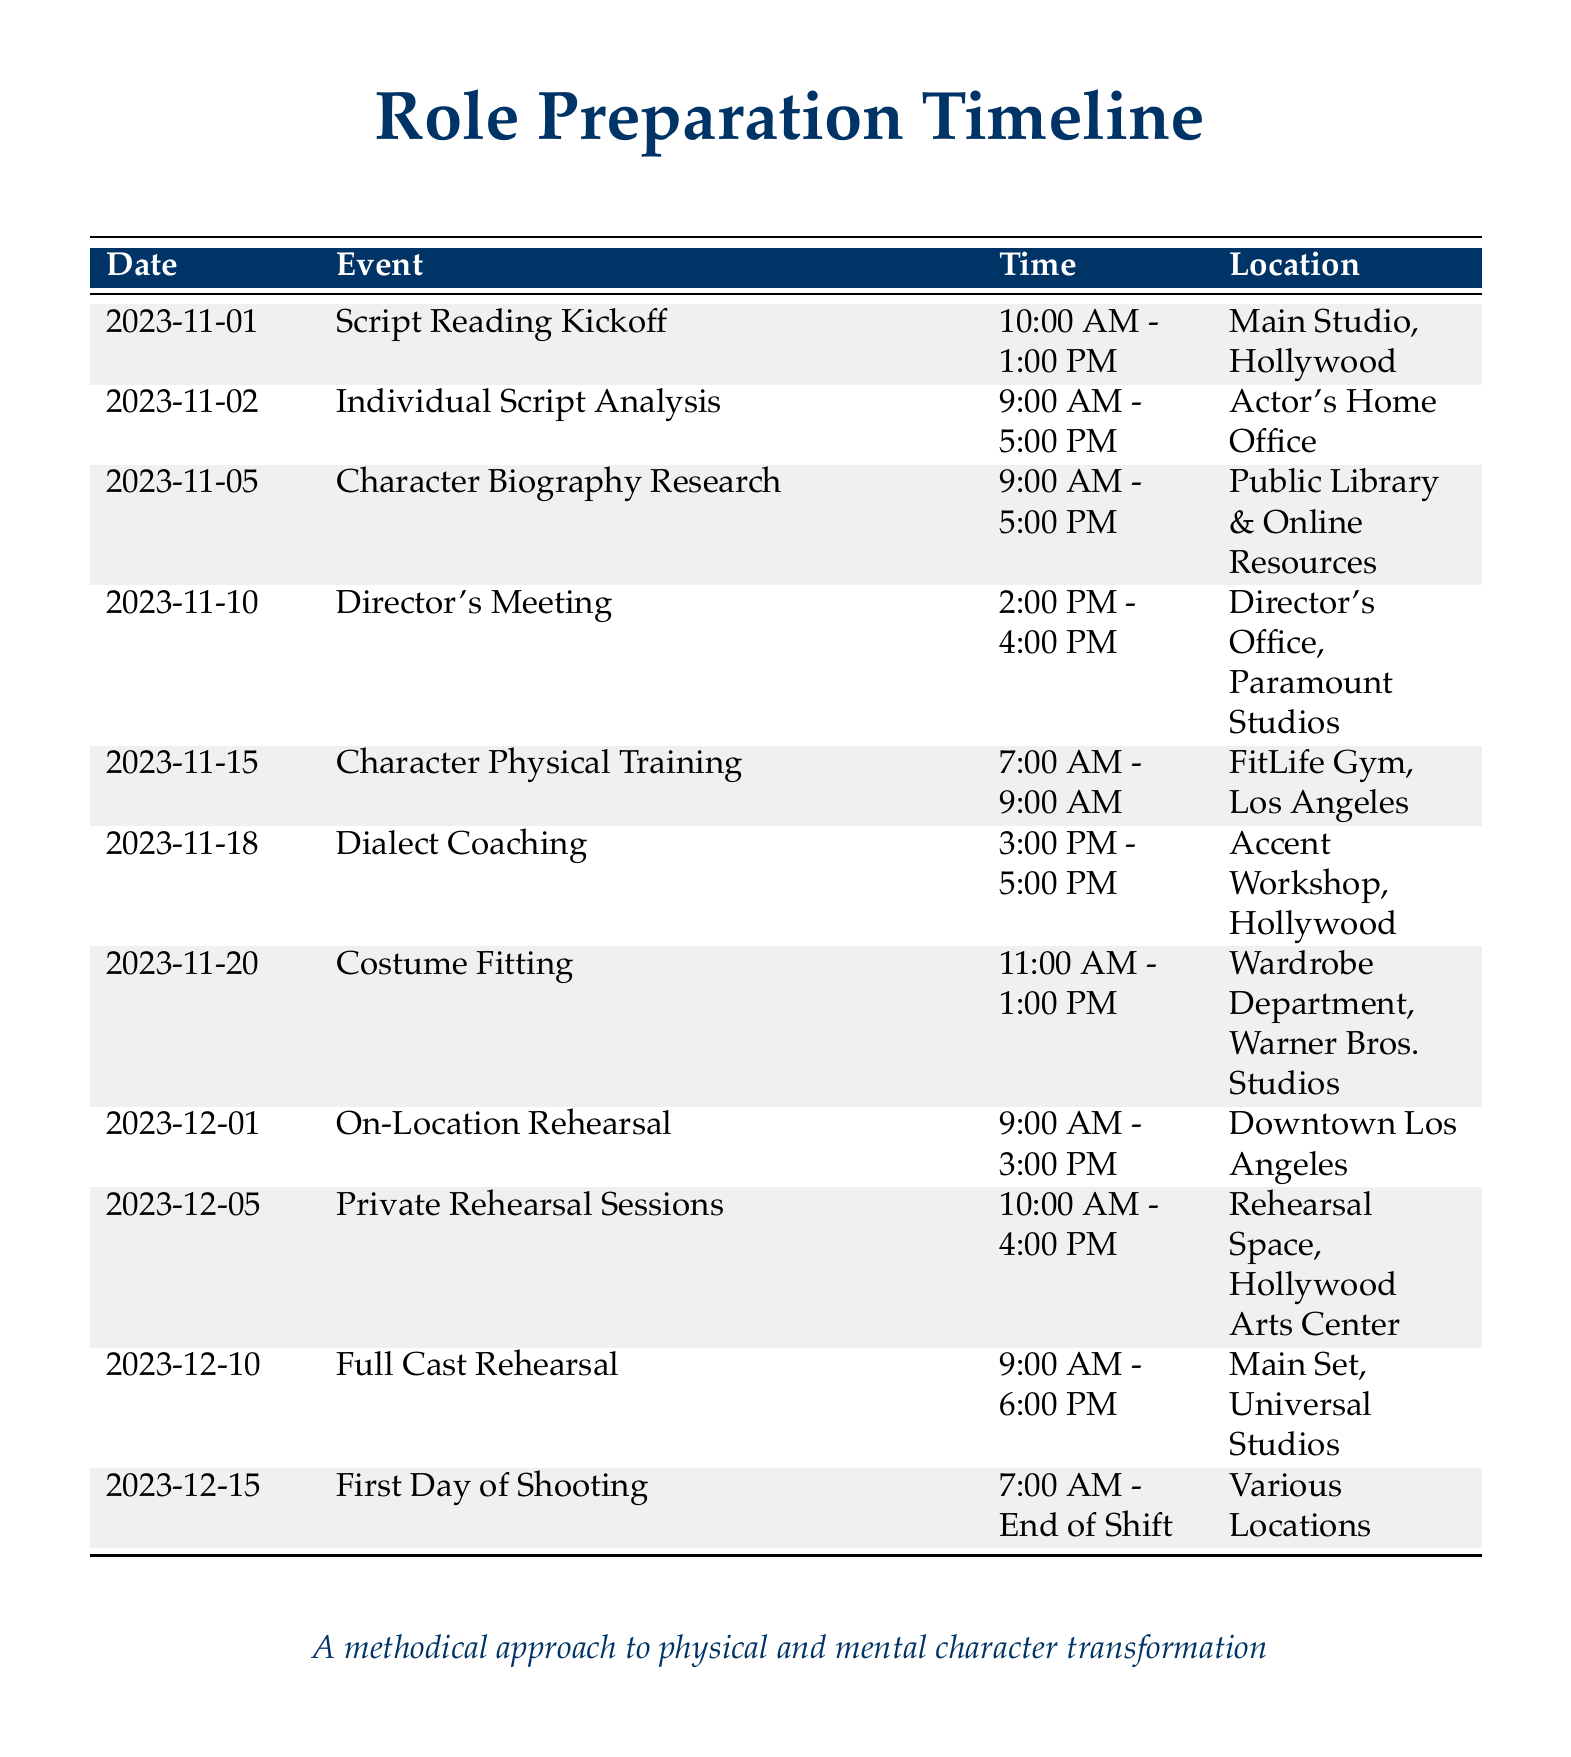What is the date of the script reading kickoff? The script reading kickoff is scheduled for November 1, 2023, as listed in the document.
Answer: November 1, 2023 What time does the dialect coaching session begin? The dialect coaching session starts at 3:00 PM on November 18, 2023, according to the timeline.
Answer: 3:00 PM Where will the costume fitting take place? The document states that the costume fitting will occur at the Wardrobe Department, Warner Bros. Studios.
Answer: Wardrobe Department, Warner Bros. Studios How long is the first day of shooting expected to last? The document indicates that the first day of shooting will start at 7:00 AM and continue until the end of the shift, but the duration is not specified.
Answer: End of Shift What event is scheduled for November 10, 2023? The document lists the Director's Meeting as the event scheduled for this date.
Answer: Director's Meeting What type of training is scheduled for November 15, 2023? The document specifies that Character Physical Training is planned for November 15, 2023.
Answer: Character Physical Training Which day has a private rehearsal session? The private rehearsal sessions are scheduled for December 5, 2023, according to the timeline provided.
Answer: December 5, 2023 What is the last event listed in the timeline? The last event in the timeline is the First Day of Shooting on December 15, 2023.
Answer: First Day of Shooting How many days are there between the script reading and the first day of shooting? From November 1 to December 15, there are 44 days, counting the start and end dates.
Answer: 44 days 